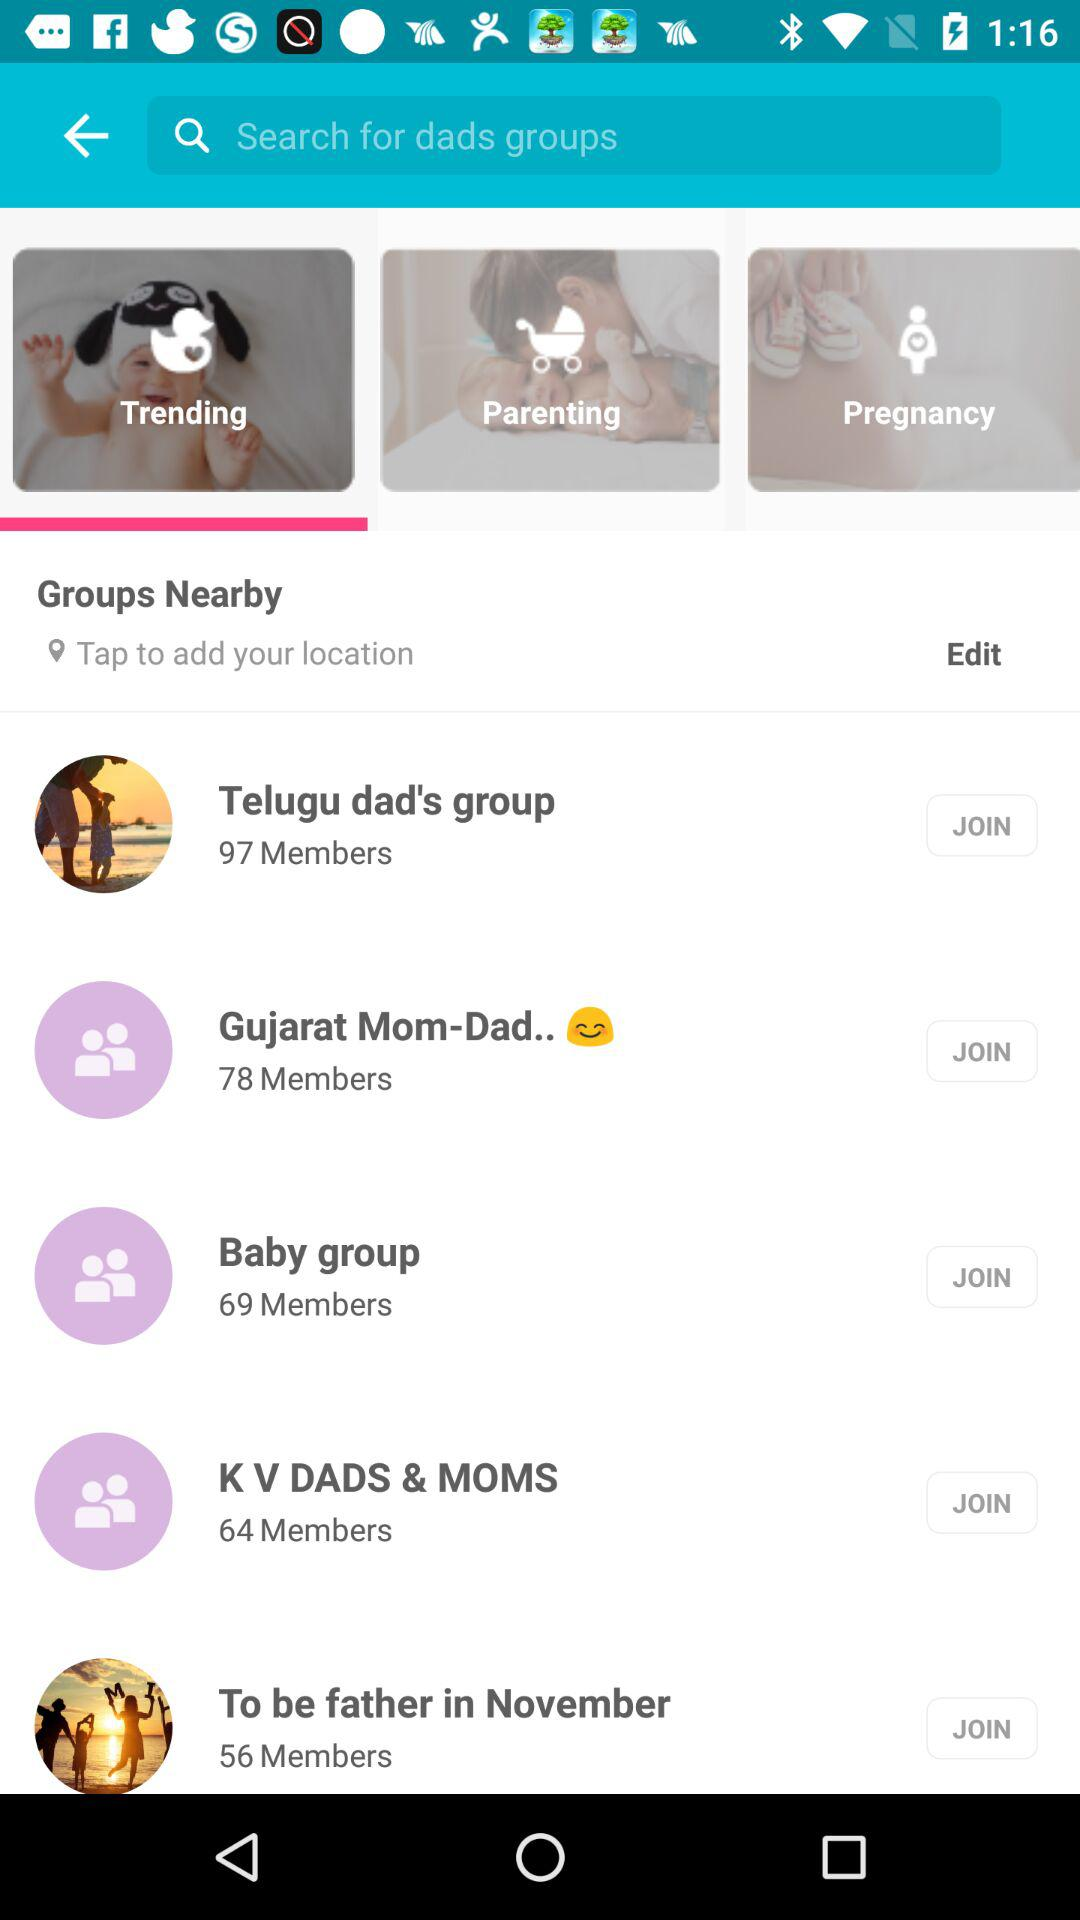Which tab is selected? The selected tab is Trending. 